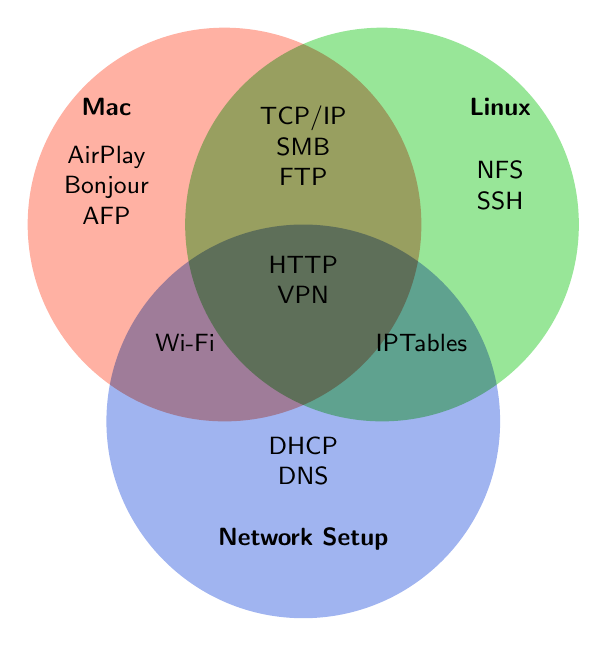What items are unique to Mac? The items that appear only in the Mac circle and not in overlapping areas with others are AirPlay, Bonjour, and AFP
Answer: AirPlay, Bonjour, AFP Which items are common to both Mac and Linux but not to Network Setup? The items in the overlapping section between Mac and Linux but outside the overlap with Network Setup are TCP/IP, SMB, and FTP.
Answer: TCP/IP, SMB, FTP How many items are there in the intersection of all three categories? Count the items listed in the region where all three circles intersect. This region lists HTTP and VPN.
Answer: 2 Which items fall under Network Setup but are not shared with Mac? These are the items found only in the circle for Network Setup and the intersection with Linux, excluding the intersection with Mac. These include DHCP, DNS, and IPTables.
Answer: DHCP, DNS, IPTables Are there more items that are unique to Mac or Network Setup? Count the number of items unique to each category. Mac has 3 unique items (AirPlay, Bonjour, AFP) and Network Setup has 2 unique items (DHCP, DNS).
Answer: Mac What protocol is shared by Mac and Network Setup but not Linux? The item is in the overlapping section between Mac and Network Setup but not in the overlap with Linux. The only protocol here is Wi-Fi.
Answer: Wi-Fi How many total unique items are there? Count all unique items from all sections of the diagram: AirPlay, Bonjour, AFP, (NFS, SSH), (DHCP, DNS), (TCP/IP, SMB, FTP), Wi-Fi, IPTables, (HTTP, VPN). There are no duplications counted here.
Answer: 14 